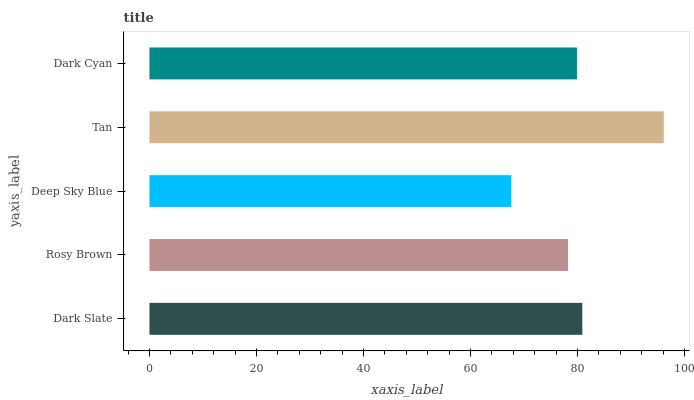Is Deep Sky Blue the minimum?
Answer yes or no. Yes. Is Tan the maximum?
Answer yes or no. Yes. Is Rosy Brown the minimum?
Answer yes or no. No. Is Rosy Brown the maximum?
Answer yes or no. No. Is Dark Slate greater than Rosy Brown?
Answer yes or no. Yes. Is Rosy Brown less than Dark Slate?
Answer yes or no. Yes. Is Rosy Brown greater than Dark Slate?
Answer yes or no. No. Is Dark Slate less than Rosy Brown?
Answer yes or no. No. Is Dark Cyan the high median?
Answer yes or no. Yes. Is Dark Cyan the low median?
Answer yes or no. Yes. Is Deep Sky Blue the high median?
Answer yes or no. No. Is Deep Sky Blue the low median?
Answer yes or no. No. 